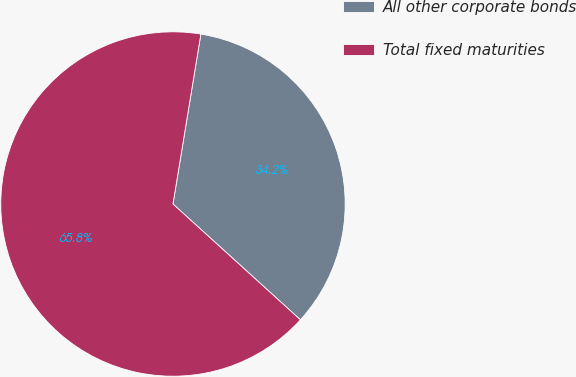<chart> <loc_0><loc_0><loc_500><loc_500><pie_chart><fcel>All other corporate bonds<fcel>Total fixed maturities<nl><fcel>34.15%<fcel>65.85%<nl></chart> 